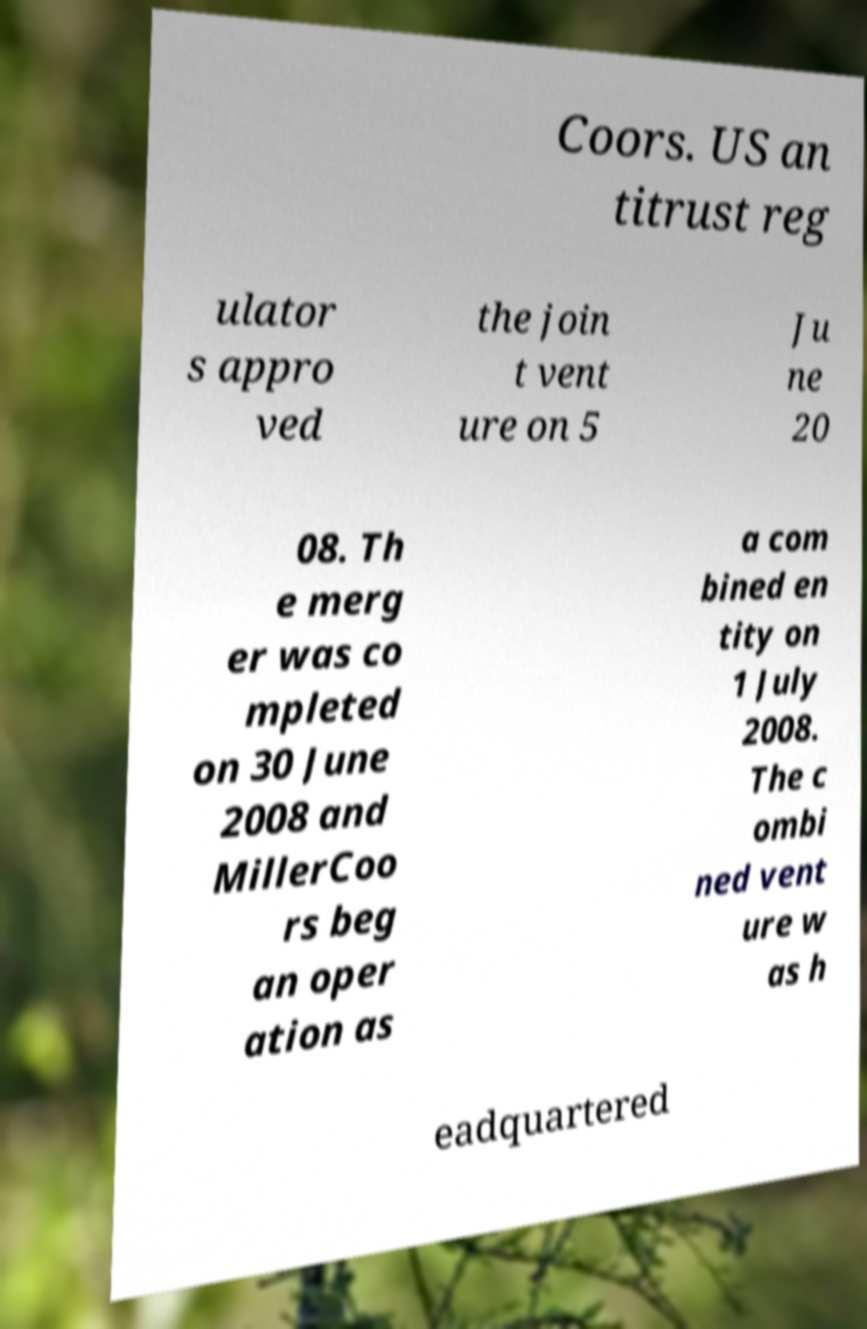There's text embedded in this image that I need extracted. Can you transcribe it verbatim? Coors. US an titrust reg ulator s appro ved the join t vent ure on 5 Ju ne 20 08. Th e merg er was co mpleted on 30 June 2008 and MillerCoo rs beg an oper ation as a com bined en tity on 1 July 2008. The c ombi ned vent ure w as h eadquartered 